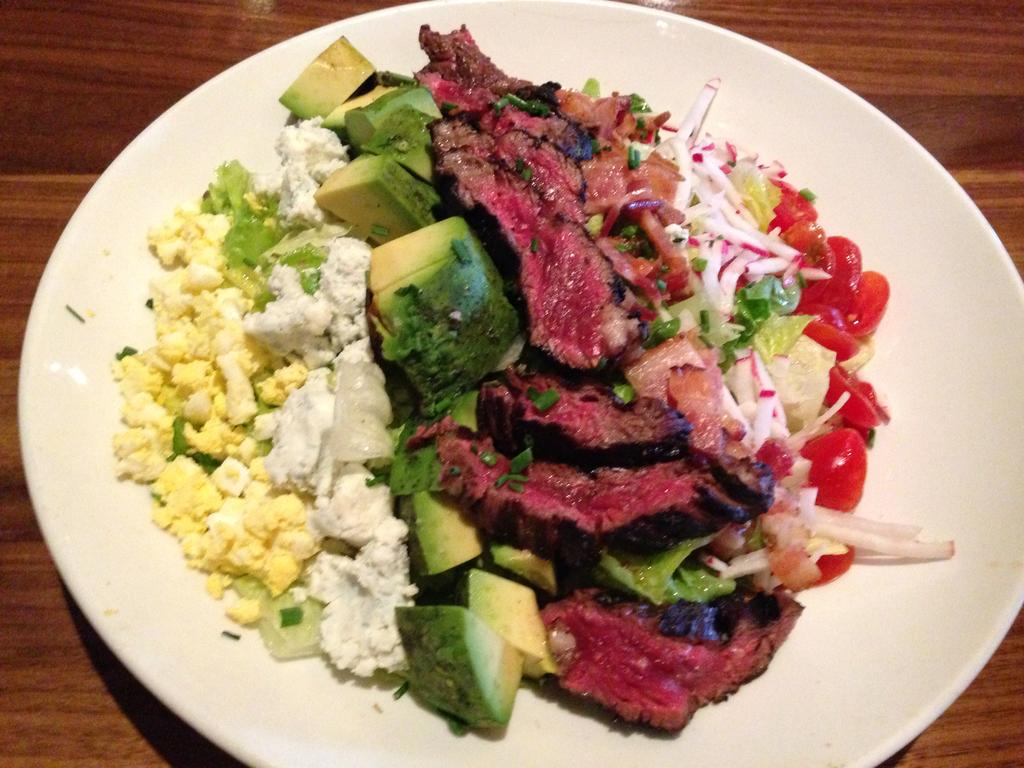What is on the table in the image? There is a plate on the table in the image. What is on the plate? There is food in the plate. How many crackers are being pushed by the expansion in the image? There are no crackers or expansion present in the image. 